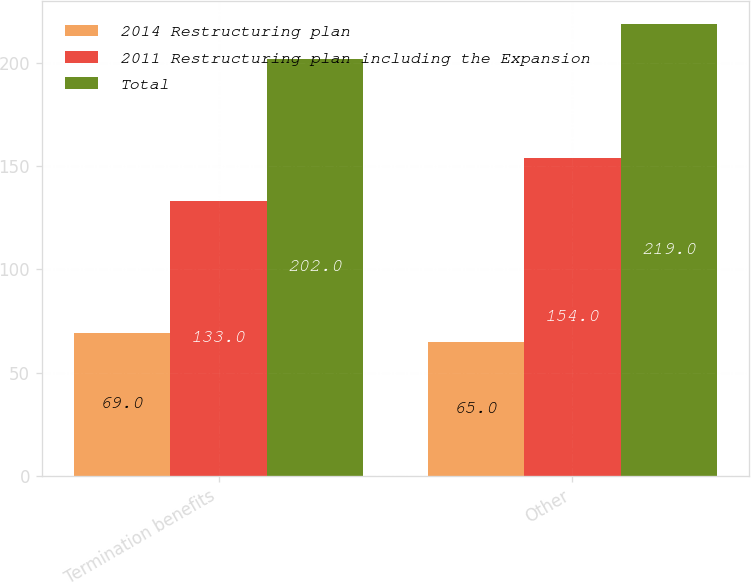<chart> <loc_0><loc_0><loc_500><loc_500><stacked_bar_chart><ecel><fcel>Termination benefits<fcel>Other<nl><fcel>2014 Restructuring plan<fcel>69<fcel>65<nl><fcel>2011 Restructuring plan including the Expansion<fcel>133<fcel>154<nl><fcel>Total<fcel>202<fcel>219<nl></chart> 